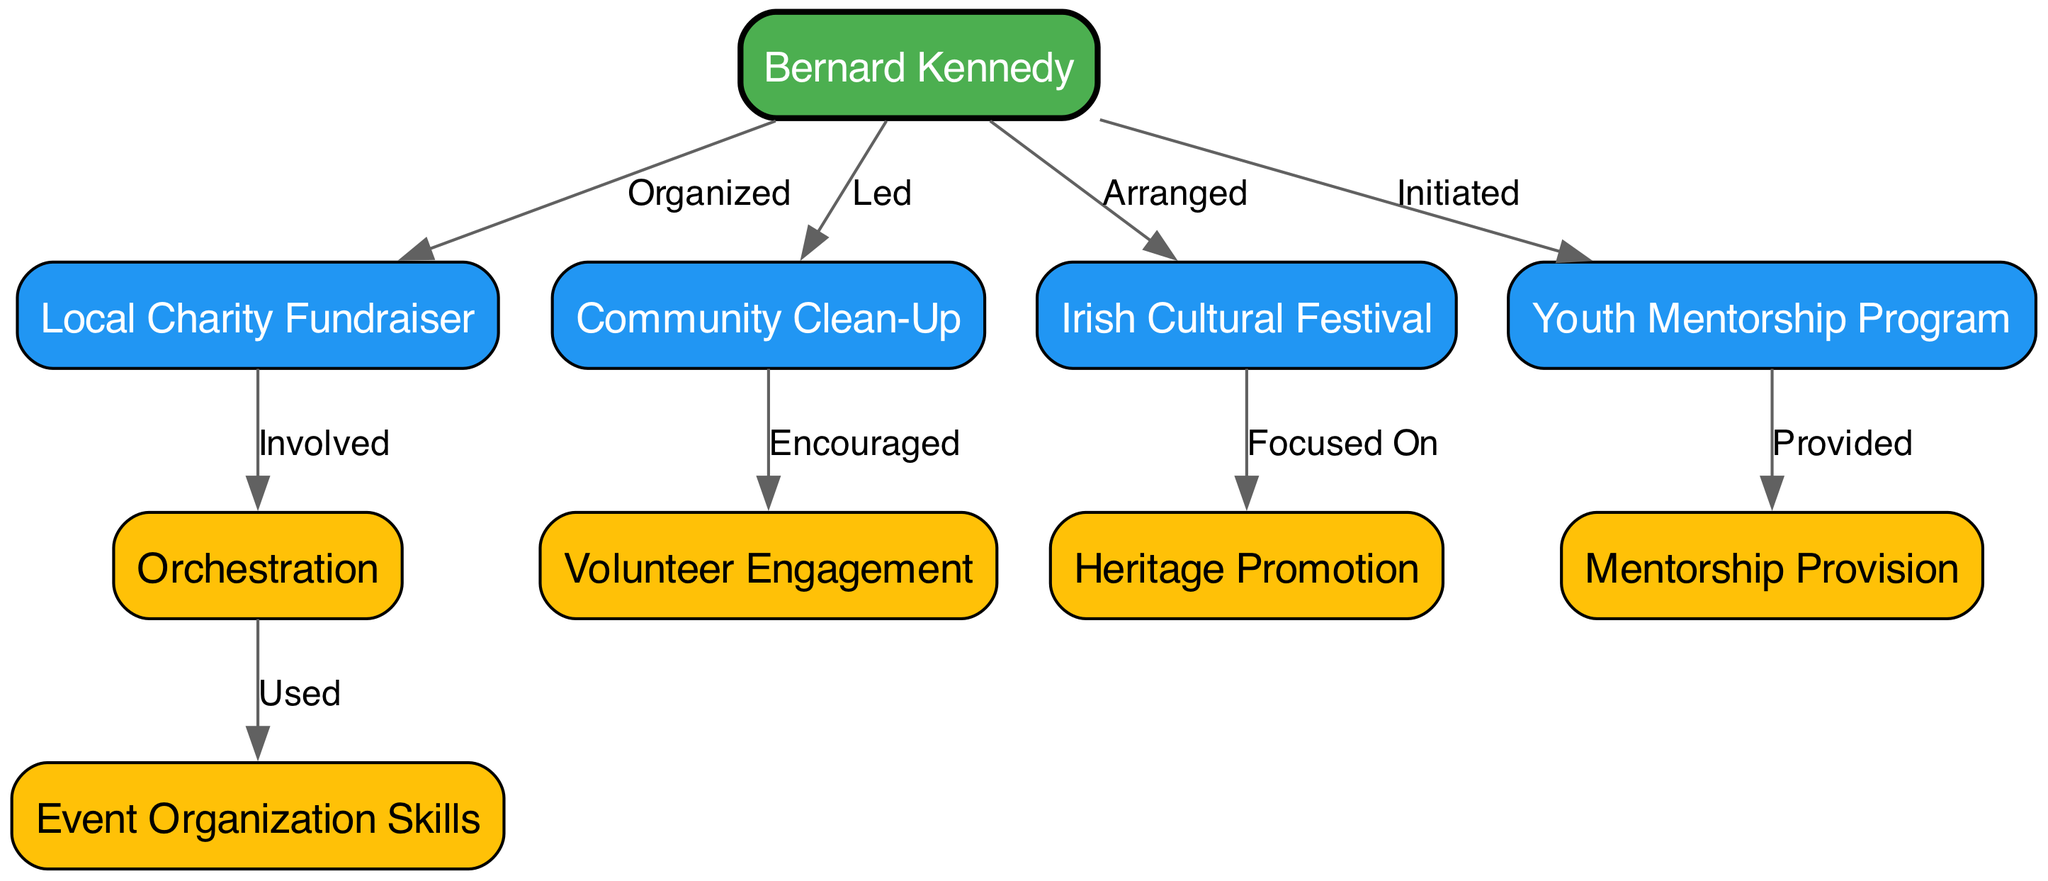What is the central figure depicted in the diagram? The central figure in the diagram is "Bernard Kennedy," as he connects to multiple community events and initiatives.
Answer: Bernard Kennedy How many community events are illustrated in the diagram? There are four community events depicted: "Local Charity Fundraiser," "Community Clean-Up," "Irish Cultural Festival," and "Youth Mentorship Program." Adding these gives a total of four distinct events.
Answer: 4 Which event did Bernard Kennedy lead? The diagram shows that Bernard Kennedy led the "Community Clean-Up," as indicated by the direct connection labeled "Led."
Answer: Community Clean-Up What skill is connected to the Local Charity Fundraiser? The "Local Charity Fundraiser" is involved with the skill labeled "Charity Fundraiser Orchestration," indicating that this skill is used in organizing the fundraiser.
Answer: Charity Fundraiser Orchestration Which cultural initiative is focused on heritage promotion? The "Irish Cultural Festival" is linked to "Heritage Promotion," meaning this initiative aims to promote Irish heritage.
Answer: Heritage Promotion How many edges connect to Bernard Kennedy? Bernard Kennedy has four edges connecting him to different events, indicating his involvement in each. Counting these connections shows the extent of his contributions.
Answer: 4 Which program was initiated by Bernard Kennedy? The program he initiated is the "Youth Mentorship Program," which is explicitly stated in the diagram.
Answer: Youth Mentorship Program What action is associated with the Community Clean-Up regarding volunteers? The "Community Clean-Up" encourages "Volunteer Engagement," showing that it aims to involve volunteers actively.
Answer: Volunteer Engagement What is the relationship between the "Youth Mentorship Program" and "Mentorship Provision"? The "Youth Mentorship Program" provides "Mentorship Provision," indicating that it aims to offer mentoring to youth participants.
Answer: Mentorship Provision 